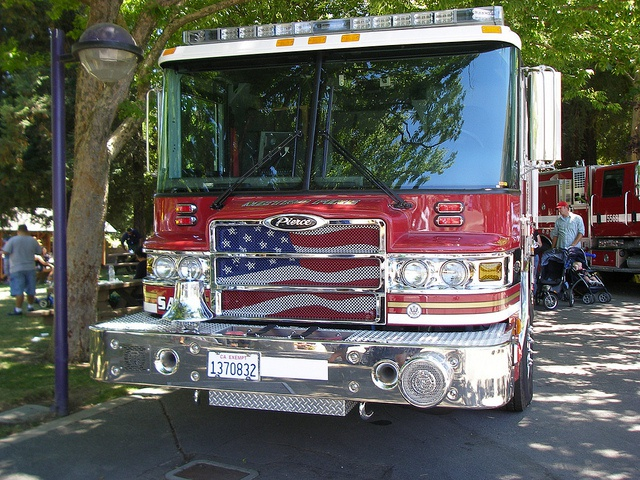Describe the objects in this image and their specific colors. I can see truck in darkgreen, black, white, gray, and darkgray tones, truck in darkgreen, black, maroon, gray, and darkgray tones, people in darkgreen, gray, blue, and navy tones, people in darkgreen, gray, lightblue, and brown tones, and people in darkgreen, black, maroon, and navy tones in this image. 